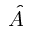Convert formula to latex. <formula><loc_0><loc_0><loc_500><loc_500>\hat { A }</formula> 